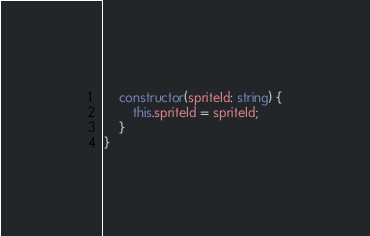Convert code to text. <code><loc_0><loc_0><loc_500><loc_500><_TypeScript_>    constructor(spriteId: string) {
        this.spriteId = spriteId;
    }
}
</code> 